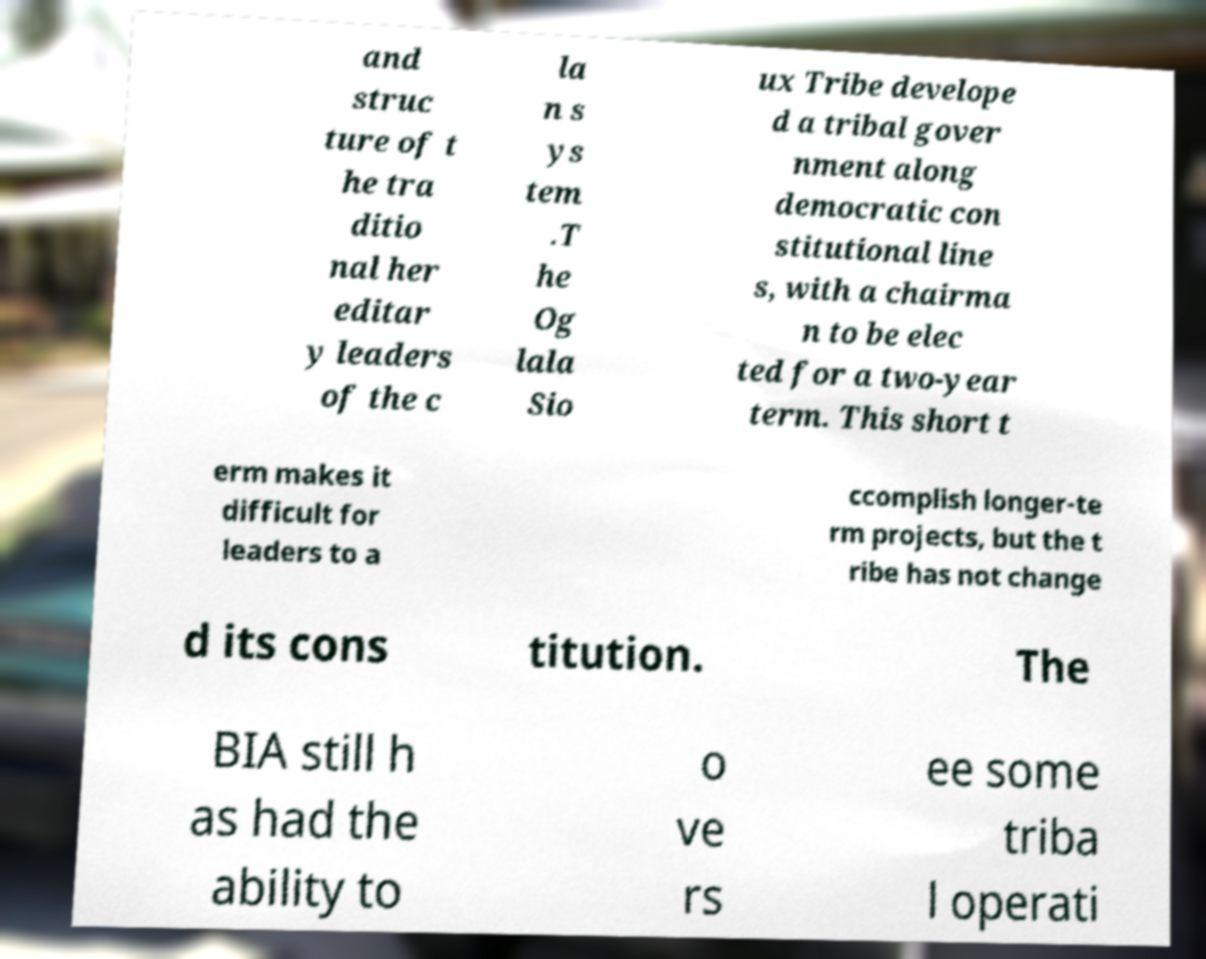There's text embedded in this image that I need extracted. Can you transcribe it verbatim? and struc ture of t he tra ditio nal her editar y leaders of the c la n s ys tem .T he Og lala Sio ux Tribe develope d a tribal gover nment along democratic con stitutional line s, with a chairma n to be elec ted for a two-year term. This short t erm makes it difficult for leaders to a ccomplish longer-te rm projects, but the t ribe has not change d its cons titution. The BIA still h as had the ability to o ve rs ee some triba l operati 